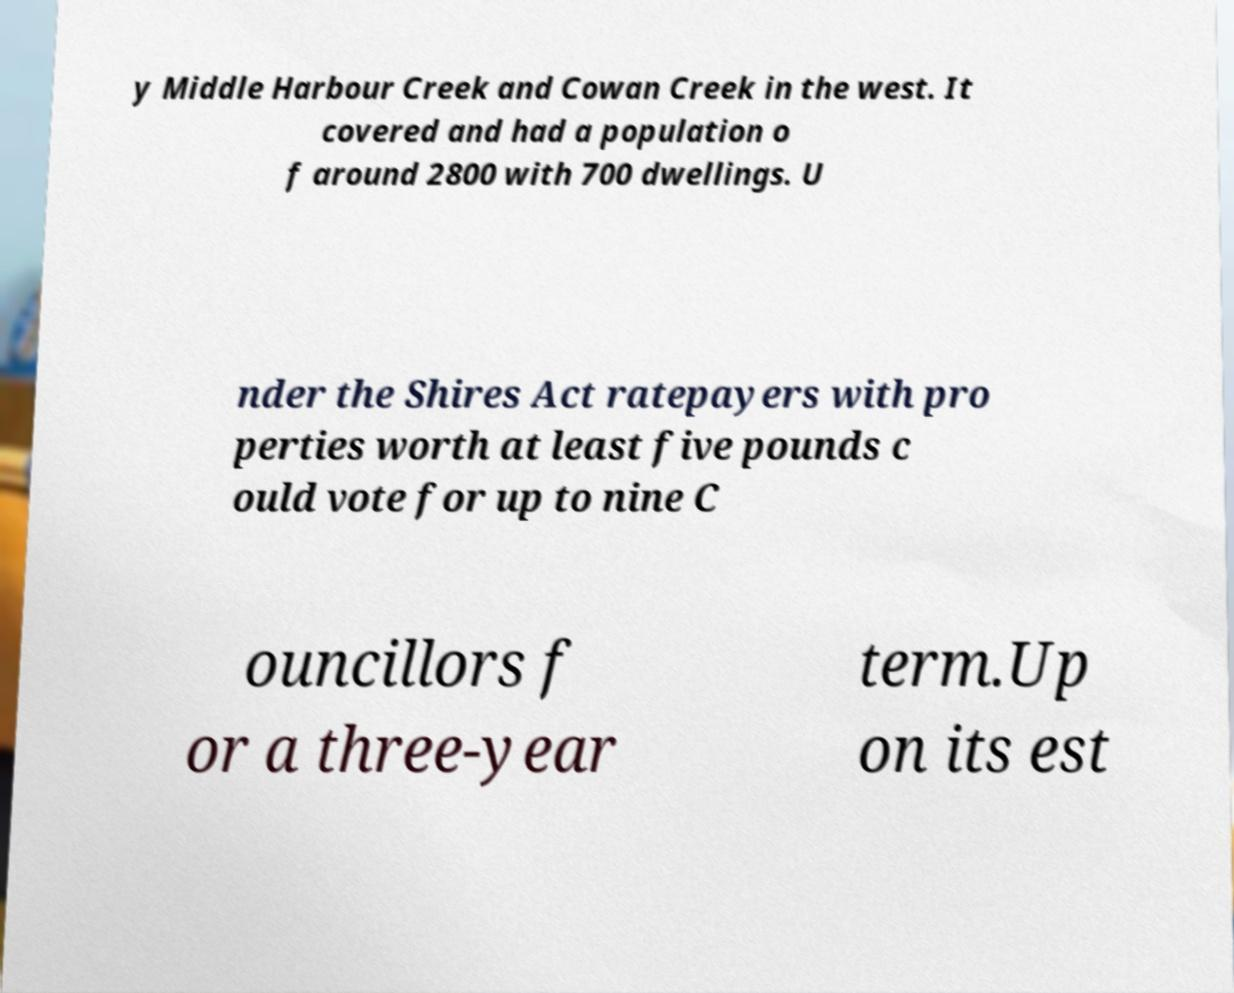Could you assist in decoding the text presented in this image and type it out clearly? y Middle Harbour Creek and Cowan Creek in the west. It covered and had a population o f around 2800 with 700 dwellings. U nder the Shires Act ratepayers with pro perties worth at least five pounds c ould vote for up to nine C ouncillors f or a three-year term.Up on its est 